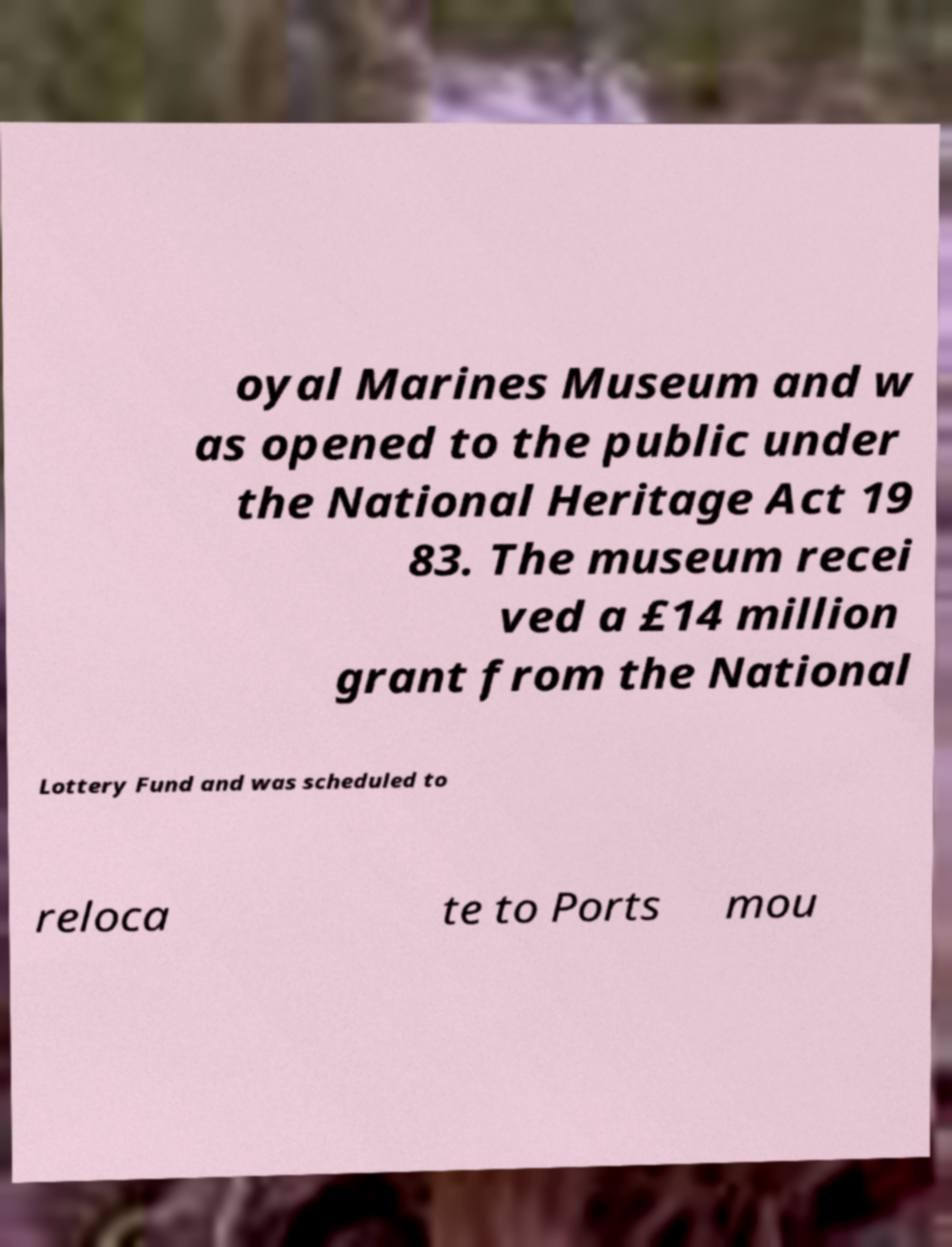Could you extract and type out the text from this image? oyal Marines Museum and w as opened to the public under the National Heritage Act 19 83. The museum recei ved a £14 million grant from the National Lottery Fund and was scheduled to reloca te to Ports mou 